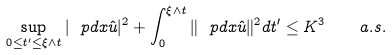Convert formula to latex. <formula><loc_0><loc_0><loc_500><loc_500>\sup _ { 0 \leq t ^ { \prime } \leq \xi \wedge t } | \ p d { x } \hat { u } | ^ { 2 } + \int _ { 0 } ^ { \xi \wedge t } \| \ p d { x } \hat { u } \| ^ { 2 } d t ^ { \prime } \leq K ^ { 3 } \quad a . s .</formula> 